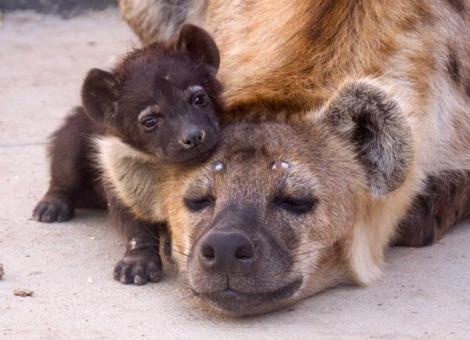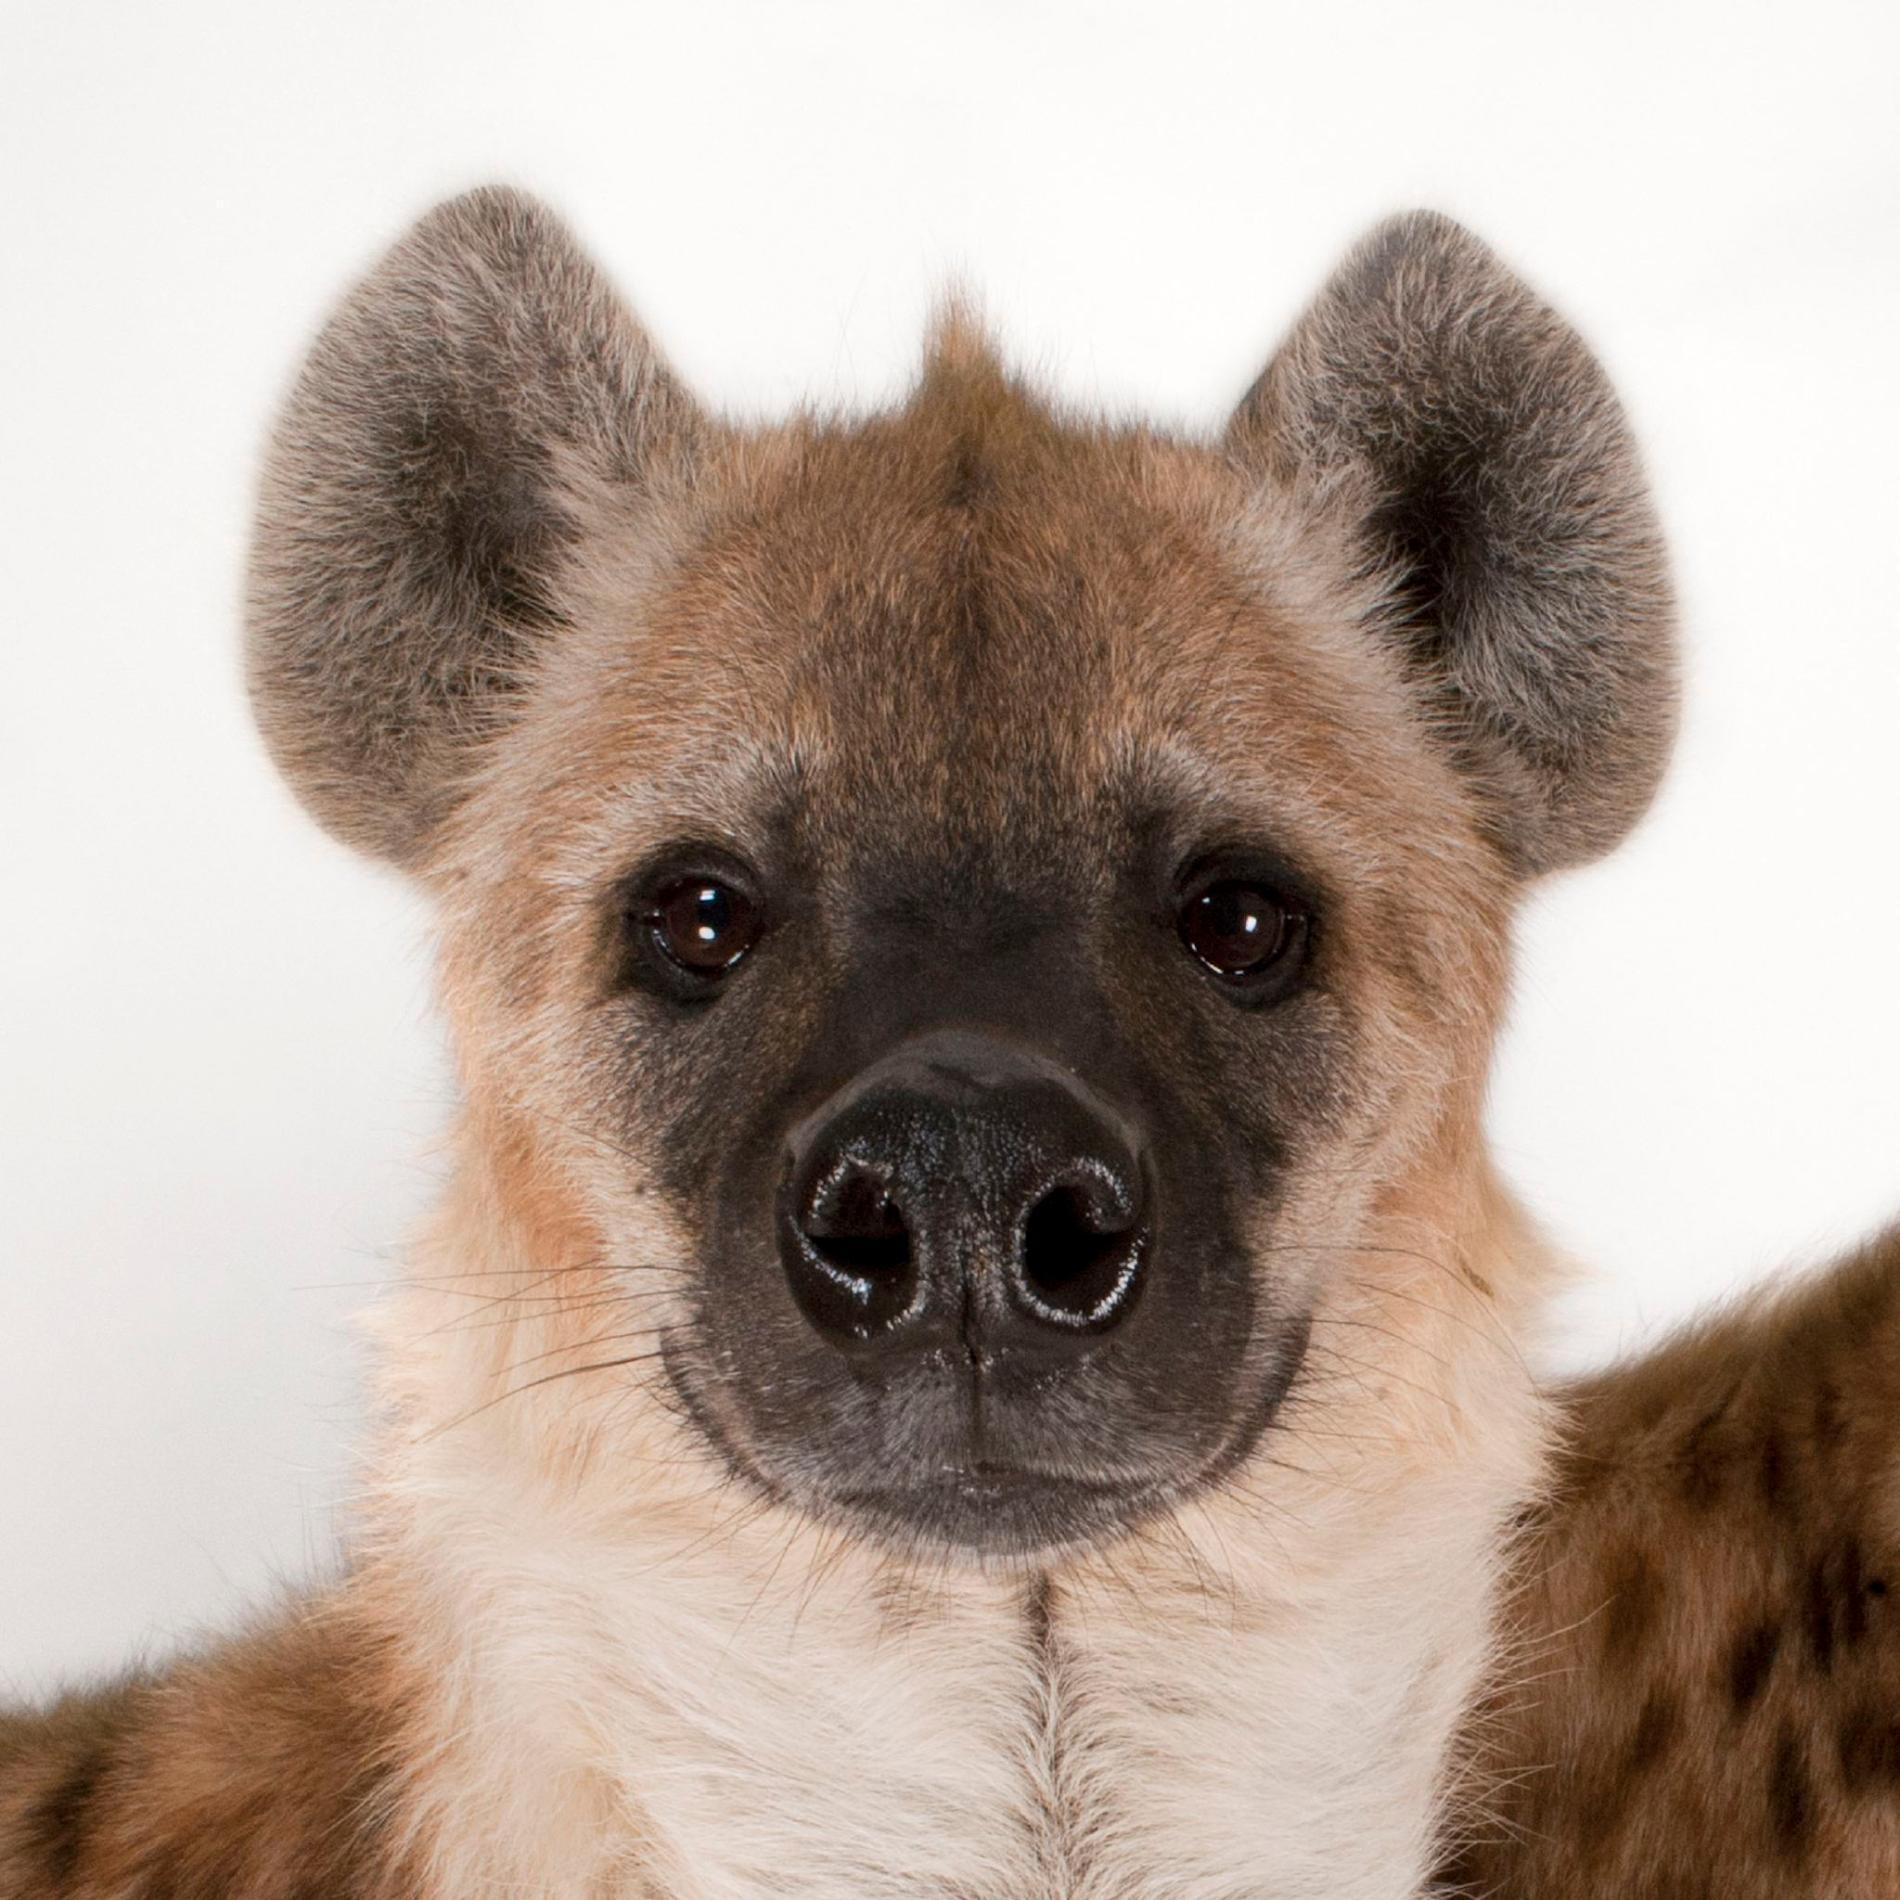The first image is the image on the left, the second image is the image on the right. For the images displayed, is the sentence "There is at least three animals total across the images." factually correct? Answer yes or no. Yes. 